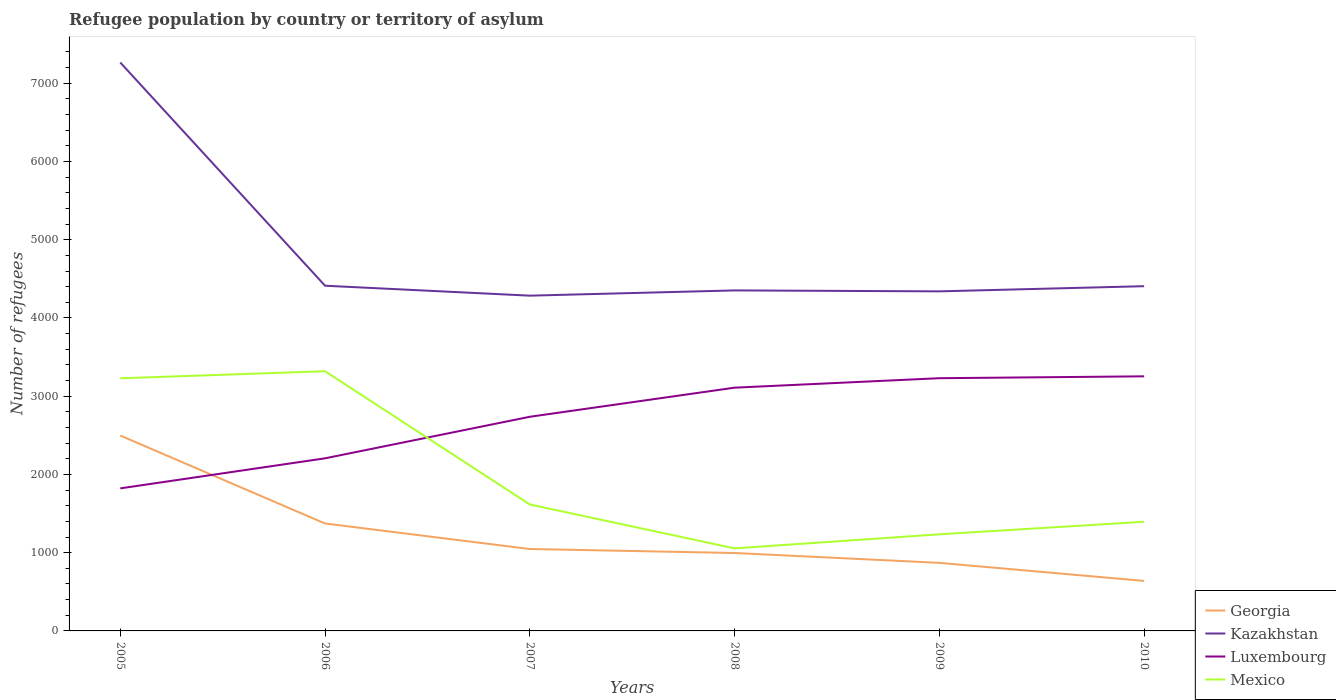How many different coloured lines are there?
Offer a terse response. 4. Is the number of lines equal to the number of legend labels?
Offer a very short reply. Yes. Across all years, what is the maximum number of refugees in Luxembourg?
Ensure brevity in your answer.  1822. In which year was the number of refugees in Mexico maximum?
Your answer should be very brief. 2008. What is the total number of refugees in Kazakhstan in the graph?
Keep it short and to the point. -121. What is the difference between the highest and the second highest number of refugees in Georgia?
Your answer should be compact. 1858. How many lines are there?
Keep it short and to the point. 4. How many years are there in the graph?
Your answer should be very brief. 6. Are the values on the major ticks of Y-axis written in scientific E-notation?
Give a very brief answer. No. Does the graph contain any zero values?
Offer a very short reply. No. Does the graph contain grids?
Make the answer very short. No. Where does the legend appear in the graph?
Your answer should be very brief. Bottom right. How many legend labels are there?
Make the answer very short. 4. How are the legend labels stacked?
Offer a terse response. Vertical. What is the title of the graph?
Offer a very short reply. Refugee population by country or territory of asylum. Does "Tonga" appear as one of the legend labels in the graph?
Provide a succinct answer. No. What is the label or title of the X-axis?
Ensure brevity in your answer.  Years. What is the label or title of the Y-axis?
Give a very brief answer. Number of refugees. What is the Number of refugees in Georgia in 2005?
Your answer should be compact. 2497. What is the Number of refugees of Kazakhstan in 2005?
Provide a short and direct response. 7265. What is the Number of refugees of Luxembourg in 2005?
Make the answer very short. 1822. What is the Number of refugees in Mexico in 2005?
Make the answer very short. 3229. What is the Number of refugees of Georgia in 2006?
Keep it short and to the point. 1373. What is the Number of refugees in Kazakhstan in 2006?
Provide a short and direct response. 4412. What is the Number of refugees in Luxembourg in 2006?
Keep it short and to the point. 2206. What is the Number of refugees in Mexico in 2006?
Your answer should be compact. 3319. What is the Number of refugees of Georgia in 2007?
Your answer should be compact. 1047. What is the Number of refugees in Kazakhstan in 2007?
Offer a terse response. 4285. What is the Number of refugees of Luxembourg in 2007?
Your response must be concise. 2737. What is the Number of refugees in Mexico in 2007?
Your response must be concise. 1616. What is the Number of refugees in Georgia in 2008?
Your response must be concise. 996. What is the Number of refugees in Kazakhstan in 2008?
Ensure brevity in your answer.  4352. What is the Number of refugees in Luxembourg in 2008?
Keep it short and to the point. 3109. What is the Number of refugees of Mexico in 2008?
Provide a succinct answer. 1055. What is the Number of refugees in Georgia in 2009?
Provide a short and direct response. 870. What is the Number of refugees of Kazakhstan in 2009?
Make the answer very short. 4340. What is the Number of refugees of Luxembourg in 2009?
Make the answer very short. 3230. What is the Number of refugees in Mexico in 2009?
Offer a terse response. 1235. What is the Number of refugees in Georgia in 2010?
Provide a short and direct response. 639. What is the Number of refugees in Kazakhstan in 2010?
Your answer should be compact. 4406. What is the Number of refugees in Luxembourg in 2010?
Your answer should be very brief. 3254. What is the Number of refugees in Mexico in 2010?
Offer a terse response. 1395. Across all years, what is the maximum Number of refugees in Georgia?
Keep it short and to the point. 2497. Across all years, what is the maximum Number of refugees in Kazakhstan?
Your answer should be very brief. 7265. Across all years, what is the maximum Number of refugees in Luxembourg?
Keep it short and to the point. 3254. Across all years, what is the maximum Number of refugees of Mexico?
Provide a short and direct response. 3319. Across all years, what is the minimum Number of refugees in Georgia?
Keep it short and to the point. 639. Across all years, what is the minimum Number of refugees of Kazakhstan?
Provide a short and direct response. 4285. Across all years, what is the minimum Number of refugees of Luxembourg?
Your response must be concise. 1822. Across all years, what is the minimum Number of refugees of Mexico?
Your answer should be very brief. 1055. What is the total Number of refugees in Georgia in the graph?
Offer a very short reply. 7422. What is the total Number of refugees in Kazakhstan in the graph?
Your answer should be compact. 2.91e+04. What is the total Number of refugees in Luxembourg in the graph?
Give a very brief answer. 1.64e+04. What is the total Number of refugees in Mexico in the graph?
Give a very brief answer. 1.18e+04. What is the difference between the Number of refugees of Georgia in 2005 and that in 2006?
Ensure brevity in your answer.  1124. What is the difference between the Number of refugees in Kazakhstan in 2005 and that in 2006?
Your answer should be compact. 2853. What is the difference between the Number of refugees in Luxembourg in 2005 and that in 2006?
Your response must be concise. -384. What is the difference between the Number of refugees of Mexico in 2005 and that in 2006?
Keep it short and to the point. -90. What is the difference between the Number of refugees of Georgia in 2005 and that in 2007?
Ensure brevity in your answer.  1450. What is the difference between the Number of refugees in Kazakhstan in 2005 and that in 2007?
Offer a terse response. 2980. What is the difference between the Number of refugees in Luxembourg in 2005 and that in 2007?
Give a very brief answer. -915. What is the difference between the Number of refugees in Mexico in 2005 and that in 2007?
Your response must be concise. 1613. What is the difference between the Number of refugees of Georgia in 2005 and that in 2008?
Make the answer very short. 1501. What is the difference between the Number of refugees in Kazakhstan in 2005 and that in 2008?
Provide a succinct answer. 2913. What is the difference between the Number of refugees of Luxembourg in 2005 and that in 2008?
Give a very brief answer. -1287. What is the difference between the Number of refugees of Mexico in 2005 and that in 2008?
Your answer should be compact. 2174. What is the difference between the Number of refugees in Georgia in 2005 and that in 2009?
Provide a short and direct response. 1627. What is the difference between the Number of refugees in Kazakhstan in 2005 and that in 2009?
Ensure brevity in your answer.  2925. What is the difference between the Number of refugees of Luxembourg in 2005 and that in 2009?
Make the answer very short. -1408. What is the difference between the Number of refugees in Mexico in 2005 and that in 2009?
Your answer should be very brief. 1994. What is the difference between the Number of refugees of Georgia in 2005 and that in 2010?
Provide a short and direct response. 1858. What is the difference between the Number of refugees in Kazakhstan in 2005 and that in 2010?
Your answer should be very brief. 2859. What is the difference between the Number of refugees of Luxembourg in 2005 and that in 2010?
Make the answer very short. -1432. What is the difference between the Number of refugees of Mexico in 2005 and that in 2010?
Your answer should be very brief. 1834. What is the difference between the Number of refugees of Georgia in 2006 and that in 2007?
Your response must be concise. 326. What is the difference between the Number of refugees in Kazakhstan in 2006 and that in 2007?
Ensure brevity in your answer.  127. What is the difference between the Number of refugees in Luxembourg in 2006 and that in 2007?
Ensure brevity in your answer.  -531. What is the difference between the Number of refugees in Mexico in 2006 and that in 2007?
Keep it short and to the point. 1703. What is the difference between the Number of refugees in Georgia in 2006 and that in 2008?
Ensure brevity in your answer.  377. What is the difference between the Number of refugees in Luxembourg in 2006 and that in 2008?
Your answer should be compact. -903. What is the difference between the Number of refugees in Mexico in 2006 and that in 2008?
Provide a succinct answer. 2264. What is the difference between the Number of refugees in Georgia in 2006 and that in 2009?
Provide a short and direct response. 503. What is the difference between the Number of refugees in Luxembourg in 2006 and that in 2009?
Ensure brevity in your answer.  -1024. What is the difference between the Number of refugees of Mexico in 2006 and that in 2009?
Your response must be concise. 2084. What is the difference between the Number of refugees in Georgia in 2006 and that in 2010?
Ensure brevity in your answer.  734. What is the difference between the Number of refugees of Kazakhstan in 2006 and that in 2010?
Provide a succinct answer. 6. What is the difference between the Number of refugees in Luxembourg in 2006 and that in 2010?
Give a very brief answer. -1048. What is the difference between the Number of refugees of Mexico in 2006 and that in 2010?
Keep it short and to the point. 1924. What is the difference between the Number of refugees in Kazakhstan in 2007 and that in 2008?
Offer a very short reply. -67. What is the difference between the Number of refugees of Luxembourg in 2007 and that in 2008?
Make the answer very short. -372. What is the difference between the Number of refugees in Mexico in 2007 and that in 2008?
Make the answer very short. 561. What is the difference between the Number of refugees of Georgia in 2007 and that in 2009?
Ensure brevity in your answer.  177. What is the difference between the Number of refugees of Kazakhstan in 2007 and that in 2009?
Offer a very short reply. -55. What is the difference between the Number of refugees of Luxembourg in 2007 and that in 2009?
Give a very brief answer. -493. What is the difference between the Number of refugees of Mexico in 2007 and that in 2009?
Make the answer very short. 381. What is the difference between the Number of refugees of Georgia in 2007 and that in 2010?
Offer a terse response. 408. What is the difference between the Number of refugees of Kazakhstan in 2007 and that in 2010?
Offer a terse response. -121. What is the difference between the Number of refugees in Luxembourg in 2007 and that in 2010?
Keep it short and to the point. -517. What is the difference between the Number of refugees of Mexico in 2007 and that in 2010?
Ensure brevity in your answer.  221. What is the difference between the Number of refugees in Georgia in 2008 and that in 2009?
Offer a very short reply. 126. What is the difference between the Number of refugees in Luxembourg in 2008 and that in 2009?
Make the answer very short. -121. What is the difference between the Number of refugees in Mexico in 2008 and that in 2009?
Provide a short and direct response. -180. What is the difference between the Number of refugees of Georgia in 2008 and that in 2010?
Provide a succinct answer. 357. What is the difference between the Number of refugees of Kazakhstan in 2008 and that in 2010?
Keep it short and to the point. -54. What is the difference between the Number of refugees of Luxembourg in 2008 and that in 2010?
Offer a terse response. -145. What is the difference between the Number of refugees of Mexico in 2008 and that in 2010?
Provide a succinct answer. -340. What is the difference between the Number of refugees of Georgia in 2009 and that in 2010?
Keep it short and to the point. 231. What is the difference between the Number of refugees in Kazakhstan in 2009 and that in 2010?
Ensure brevity in your answer.  -66. What is the difference between the Number of refugees of Mexico in 2009 and that in 2010?
Offer a terse response. -160. What is the difference between the Number of refugees in Georgia in 2005 and the Number of refugees in Kazakhstan in 2006?
Provide a succinct answer. -1915. What is the difference between the Number of refugees of Georgia in 2005 and the Number of refugees of Luxembourg in 2006?
Give a very brief answer. 291. What is the difference between the Number of refugees of Georgia in 2005 and the Number of refugees of Mexico in 2006?
Offer a very short reply. -822. What is the difference between the Number of refugees of Kazakhstan in 2005 and the Number of refugees of Luxembourg in 2006?
Provide a short and direct response. 5059. What is the difference between the Number of refugees of Kazakhstan in 2005 and the Number of refugees of Mexico in 2006?
Your answer should be compact. 3946. What is the difference between the Number of refugees in Luxembourg in 2005 and the Number of refugees in Mexico in 2006?
Keep it short and to the point. -1497. What is the difference between the Number of refugees of Georgia in 2005 and the Number of refugees of Kazakhstan in 2007?
Ensure brevity in your answer.  -1788. What is the difference between the Number of refugees in Georgia in 2005 and the Number of refugees in Luxembourg in 2007?
Offer a very short reply. -240. What is the difference between the Number of refugees of Georgia in 2005 and the Number of refugees of Mexico in 2007?
Make the answer very short. 881. What is the difference between the Number of refugees of Kazakhstan in 2005 and the Number of refugees of Luxembourg in 2007?
Your answer should be compact. 4528. What is the difference between the Number of refugees of Kazakhstan in 2005 and the Number of refugees of Mexico in 2007?
Offer a very short reply. 5649. What is the difference between the Number of refugees of Luxembourg in 2005 and the Number of refugees of Mexico in 2007?
Your answer should be compact. 206. What is the difference between the Number of refugees of Georgia in 2005 and the Number of refugees of Kazakhstan in 2008?
Provide a short and direct response. -1855. What is the difference between the Number of refugees in Georgia in 2005 and the Number of refugees in Luxembourg in 2008?
Your answer should be very brief. -612. What is the difference between the Number of refugees of Georgia in 2005 and the Number of refugees of Mexico in 2008?
Provide a short and direct response. 1442. What is the difference between the Number of refugees of Kazakhstan in 2005 and the Number of refugees of Luxembourg in 2008?
Provide a succinct answer. 4156. What is the difference between the Number of refugees of Kazakhstan in 2005 and the Number of refugees of Mexico in 2008?
Ensure brevity in your answer.  6210. What is the difference between the Number of refugees in Luxembourg in 2005 and the Number of refugees in Mexico in 2008?
Your response must be concise. 767. What is the difference between the Number of refugees of Georgia in 2005 and the Number of refugees of Kazakhstan in 2009?
Keep it short and to the point. -1843. What is the difference between the Number of refugees of Georgia in 2005 and the Number of refugees of Luxembourg in 2009?
Provide a succinct answer. -733. What is the difference between the Number of refugees in Georgia in 2005 and the Number of refugees in Mexico in 2009?
Your answer should be compact. 1262. What is the difference between the Number of refugees of Kazakhstan in 2005 and the Number of refugees of Luxembourg in 2009?
Offer a very short reply. 4035. What is the difference between the Number of refugees in Kazakhstan in 2005 and the Number of refugees in Mexico in 2009?
Give a very brief answer. 6030. What is the difference between the Number of refugees in Luxembourg in 2005 and the Number of refugees in Mexico in 2009?
Ensure brevity in your answer.  587. What is the difference between the Number of refugees of Georgia in 2005 and the Number of refugees of Kazakhstan in 2010?
Give a very brief answer. -1909. What is the difference between the Number of refugees of Georgia in 2005 and the Number of refugees of Luxembourg in 2010?
Ensure brevity in your answer.  -757. What is the difference between the Number of refugees in Georgia in 2005 and the Number of refugees in Mexico in 2010?
Your answer should be very brief. 1102. What is the difference between the Number of refugees in Kazakhstan in 2005 and the Number of refugees in Luxembourg in 2010?
Keep it short and to the point. 4011. What is the difference between the Number of refugees in Kazakhstan in 2005 and the Number of refugees in Mexico in 2010?
Give a very brief answer. 5870. What is the difference between the Number of refugees of Luxembourg in 2005 and the Number of refugees of Mexico in 2010?
Offer a very short reply. 427. What is the difference between the Number of refugees of Georgia in 2006 and the Number of refugees of Kazakhstan in 2007?
Give a very brief answer. -2912. What is the difference between the Number of refugees of Georgia in 2006 and the Number of refugees of Luxembourg in 2007?
Provide a succinct answer. -1364. What is the difference between the Number of refugees in Georgia in 2006 and the Number of refugees in Mexico in 2007?
Provide a succinct answer. -243. What is the difference between the Number of refugees in Kazakhstan in 2006 and the Number of refugees in Luxembourg in 2007?
Make the answer very short. 1675. What is the difference between the Number of refugees of Kazakhstan in 2006 and the Number of refugees of Mexico in 2007?
Provide a short and direct response. 2796. What is the difference between the Number of refugees in Luxembourg in 2006 and the Number of refugees in Mexico in 2007?
Your response must be concise. 590. What is the difference between the Number of refugees of Georgia in 2006 and the Number of refugees of Kazakhstan in 2008?
Your answer should be compact. -2979. What is the difference between the Number of refugees in Georgia in 2006 and the Number of refugees in Luxembourg in 2008?
Offer a very short reply. -1736. What is the difference between the Number of refugees of Georgia in 2006 and the Number of refugees of Mexico in 2008?
Ensure brevity in your answer.  318. What is the difference between the Number of refugees of Kazakhstan in 2006 and the Number of refugees of Luxembourg in 2008?
Ensure brevity in your answer.  1303. What is the difference between the Number of refugees in Kazakhstan in 2006 and the Number of refugees in Mexico in 2008?
Offer a terse response. 3357. What is the difference between the Number of refugees in Luxembourg in 2006 and the Number of refugees in Mexico in 2008?
Offer a very short reply. 1151. What is the difference between the Number of refugees of Georgia in 2006 and the Number of refugees of Kazakhstan in 2009?
Offer a very short reply. -2967. What is the difference between the Number of refugees in Georgia in 2006 and the Number of refugees in Luxembourg in 2009?
Offer a terse response. -1857. What is the difference between the Number of refugees in Georgia in 2006 and the Number of refugees in Mexico in 2009?
Your response must be concise. 138. What is the difference between the Number of refugees in Kazakhstan in 2006 and the Number of refugees in Luxembourg in 2009?
Your answer should be compact. 1182. What is the difference between the Number of refugees in Kazakhstan in 2006 and the Number of refugees in Mexico in 2009?
Your response must be concise. 3177. What is the difference between the Number of refugees of Luxembourg in 2006 and the Number of refugees of Mexico in 2009?
Provide a short and direct response. 971. What is the difference between the Number of refugees of Georgia in 2006 and the Number of refugees of Kazakhstan in 2010?
Give a very brief answer. -3033. What is the difference between the Number of refugees of Georgia in 2006 and the Number of refugees of Luxembourg in 2010?
Your answer should be compact. -1881. What is the difference between the Number of refugees in Georgia in 2006 and the Number of refugees in Mexico in 2010?
Ensure brevity in your answer.  -22. What is the difference between the Number of refugees of Kazakhstan in 2006 and the Number of refugees of Luxembourg in 2010?
Your answer should be compact. 1158. What is the difference between the Number of refugees of Kazakhstan in 2006 and the Number of refugees of Mexico in 2010?
Provide a succinct answer. 3017. What is the difference between the Number of refugees in Luxembourg in 2006 and the Number of refugees in Mexico in 2010?
Provide a succinct answer. 811. What is the difference between the Number of refugees of Georgia in 2007 and the Number of refugees of Kazakhstan in 2008?
Provide a succinct answer. -3305. What is the difference between the Number of refugees of Georgia in 2007 and the Number of refugees of Luxembourg in 2008?
Your answer should be very brief. -2062. What is the difference between the Number of refugees of Kazakhstan in 2007 and the Number of refugees of Luxembourg in 2008?
Your answer should be very brief. 1176. What is the difference between the Number of refugees of Kazakhstan in 2007 and the Number of refugees of Mexico in 2008?
Give a very brief answer. 3230. What is the difference between the Number of refugees in Luxembourg in 2007 and the Number of refugees in Mexico in 2008?
Keep it short and to the point. 1682. What is the difference between the Number of refugees in Georgia in 2007 and the Number of refugees in Kazakhstan in 2009?
Your answer should be very brief. -3293. What is the difference between the Number of refugees in Georgia in 2007 and the Number of refugees in Luxembourg in 2009?
Make the answer very short. -2183. What is the difference between the Number of refugees in Georgia in 2007 and the Number of refugees in Mexico in 2009?
Provide a succinct answer. -188. What is the difference between the Number of refugees in Kazakhstan in 2007 and the Number of refugees in Luxembourg in 2009?
Keep it short and to the point. 1055. What is the difference between the Number of refugees in Kazakhstan in 2007 and the Number of refugees in Mexico in 2009?
Ensure brevity in your answer.  3050. What is the difference between the Number of refugees in Luxembourg in 2007 and the Number of refugees in Mexico in 2009?
Offer a very short reply. 1502. What is the difference between the Number of refugees of Georgia in 2007 and the Number of refugees of Kazakhstan in 2010?
Give a very brief answer. -3359. What is the difference between the Number of refugees in Georgia in 2007 and the Number of refugees in Luxembourg in 2010?
Your response must be concise. -2207. What is the difference between the Number of refugees of Georgia in 2007 and the Number of refugees of Mexico in 2010?
Provide a short and direct response. -348. What is the difference between the Number of refugees in Kazakhstan in 2007 and the Number of refugees in Luxembourg in 2010?
Ensure brevity in your answer.  1031. What is the difference between the Number of refugees of Kazakhstan in 2007 and the Number of refugees of Mexico in 2010?
Your answer should be compact. 2890. What is the difference between the Number of refugees of Luxembourg in 2007 and the Number of refugees of Mexico in 2010?
Give a very brief answer. 1342. What is the difference between the Number of refugees in Georgia in 2008 and the Number of refugees in Kazakhstan in 2009?
Offer a very short reply. -3344. What is the difference between the Number of refugees in Georgia in 2008 and the Number of refugees in Luxembourg in 2009?
Provide a succinct answer. -2234. What is the difference between the Number of refugees of Georgia in 2008 and the Number of refugees of Mexico in 2009?
Your answer should be compact. -239. What is the difference between the Number of refugees in Kazakhstan in 2008 and the Number of refugees in Luxembourg in 2009?
Give a very brief answer. 1122. What is the difference between the Number of refugees of Kazakhstan in 2008 and the Number of refugees of Mexico in 2009?
Your response must be concise. 3117. What is the difference between the Number of refugees in Luxembourg in 2008 and the Number of refugees in Mexico in 2009?
Your answer should be compact. 1874. What is the difference between the Number of refugees of Georgia in 2008 and the Number of refugees of Kazakhstan in 2010?
Offer a terse response. -3410. What is the difference between the Number of refugees in Georgia in 2008 and the Number of refugees in Luxembourg in 2010?
Give a very brief answer. -2258. What is the difference between the Number of refugees in Georgia in 2008 and the Number of refugees in Mexico in 2010?
Give a very brief answer. -399. What is the difference between the Number of refugees in Kazakhstan in 2008 and the Number of refugees in Luxembourg in 2010?
Ensure brevity in your answer.  1098. What is the difference between the Number of refugees of Kazakhstan in 2008 and the Number of refugees of Mexico in 2010?
Keep it short and to the point. 2957. What is the difference between the Number of refugees in Luxembourg in 2008 and the Number of refugees in Mexico in 2010?
Offer a terse response. 1714. What is the difference between the Number of refugees of Georgia in 2009 and the Number of refugees of Kazakhstan in 2010?
Your response must be concise. -3536. What is the difference between the Number of refugees of Georgia in 2009 and the Number of refugees of Luxembourg in 2010?
Offer a very short reply. -2384. What is the difference between the Number of refugees of Georgia in 2009 and the Number of refugees of Mexico in 2010?
Offer a terse response. -525. What is the difference between the Number of refugees of Kazakhstan in 2009 and the Number of refugees of Luxembourg in 2010?
Make the answer very short. 1086. What is the difference between the Number of refugees in Kazakhstan in 2009 and the Number of refugees in Mexico in 2010?
Provide a succinct answer. 2945. What is the difference between the Number of refugees of Luxembourg in 2009 and the Number of refugees of Mexico in 2010?
Offer a terse response. 1835. What is the average Number of refugees in Georgia per year?
Your answer should be compact. 1237. What is the average Number of refugees of Kazakhstan per year?
Offer a very short reply. 4843.33. What is the average Number of refugees in Luxembourg per year?
Ensure brevity in your answer.  2726.33. What is the average Number of refugees of Mexico per year?
Provide a short and direct response. 1974.83. In the year 2005, what is the difference between the Number of refugees of Georgia and Number of refugees of Kazakhstan?
Provide a succinct answer. -4768. In the year 2005, what is the difference between the Number of refugees in Georgia and Number of refugees in Luxembourg?
Give a very brief answer. 675. In the year 2005, what is the difference between the Number of refugees in Georgia and Number of refugees in Mexico?
Your answer should be very brief. -732. In the year 2005, what is the difference between the Number of refugees of Kazakhstan and Number of refugees of Luxembourg?
Keep it short and to the point. 5443. In the year 2005, what is the difference between the Number of refugees in Kazakhstan and Number of refugees in Mexico?
Give a very brief answer. 4036. In the year 2005, what is the difference between the Number of refugees in Luxembourg and Number of refugees in Mexico?
Make the answer very short. -1407. In the year 2006, what is the difference between the Number of refugees of Georgia and Number of refugees of Kazakhstan?
Keep it short and to the point. -3039. In the year 2006, what is the difference between the Number of refugees in Georgia and Number of refugees in Luxembourg?
Provide a short and direct response. -833. In the year 2006, what is the difference between the Number of refugees of Georgia and Number of refugees of Mexico?
Ensure brevity in your answer.  -1946. In the year 2006, what is the difference between the Number of refugees of Kazakhstan and Number of refugees of Luxembourg?
Your answer should be compact. 2206. In the year 2006, what is the difference between the Number of refugees in Kazakhstan and Number of refugees in Mexico?
Your response must be concise. 1093. In the year 2006, what is the difference between the Number of refugees of Luxembourg and Number of refugees of Mexico?
Your answer should be very brief. -1113. In the year 2007, what is the difference between the Number of refugees of Georgia and Number of refugees of Kazakhstan?
Keep it short and to the point. -3238. In the year 2007, what is the difference between the Number of refugees in Georgia and Number of refugees in Luxembourg?
Provide a succinct answer. -1690. In the year 2007, what is the difference between the Number of refugees in Georgia and Number of refugees in Mexico?
Offer a very short reply. -569. In the year 2007, what is the difference between the Number of refugees of Kazakhstan and Number of refugees of Luxembourg?
Make the answer very short. 1548. In the year 2007, what is the difference between the Number of refugees of Kazakhstan and Number of refugees of Mexico?
Your response must be concise. 2669. In the year 2007, what is the difference between the Number of refugees in Luxembourg and Number of refugees in Mexico?
Offer a very short reply. 1121. In the year 2008, what is the difference between the Number of refugees in Georgia and Number of refugees in Kazakhstan?
Make the answer very short. -3356. In the year 2008, what is the difference between the Number of refugees of Georgia and Number of refugees of Luxembourg?
Offer a very short reply. -2113. In the year 2008, what is the difference between the Number of refugees in Georgia and Number of refugees in Mexico?
Offer a terse response. -59. In the year 2008, what is the difference between the Number of refugees in Kazakhstan and Number of refugees in Luxembourg?
Make the answer very short. 1243. In the year 2008, what is the difference between the Number of refugees of Kazakhstan and Number of refugees of Mexico?
Make the answer very short. 3297. In the year 2008, what is the difference between the Number of refugees of Luxembourg and Number of refugees of Mexico?
Provide a succinct answer. 2054. In the year 2009, what is the difference between the Number of refugees in Georgia and Number of refugees in Kazakhstan?
Your answer should be very brief. -3470. In the year 2009, what is the difference between the Number of refugees in Georgia and Number of refugees in Luxembourg?
Offer a terse response. -2360. In the year 2009, what is the difference between the Number of refugees of Georgia and Number of refugees of Mexico?
Provide a succinct answer. -365. In the year 2009, what is the difference between the Number of refugees of Kazakhstan and Number of refugees of Luxembourg?
Your response must be concise. 1110. In the year 2009, what is the difference between the Number of refugees of Kazakhstan and Number of refugees of Mexico?
Provide a short and direct response. 3105. In the year 2009, what is the difference between the Number of refugees of Luxembourg and Number of refugees of Mexico?
Offer a terse response. 1995. In the year 2010, what is the difference between the Number of refugees in Georgia and Number of refugees in Kazakhstan?
Offer a very short reply. -3767. In the year 2010, what is the difference between the Number of refugees in Georgia and Number of refugees in Luxembourg?
Offer a very short reply. -2615. In the year 2010, what is the difference between the Number of refugees in Georgia and Number of refugees in Mexico?
Your answer should be compact. -756. In the year 2010, what is the difference between the Number of refugees in Kazakhstan and Number of refugees in Luxembourg?
Your answer should be compact. 1152. In the year 2010, what is the difference between the Number of refugees of Kazakhstan and Number of refugees of Mexico?
Ensure brevity in your answer.  3011. In the year 2010, what is the difference between the Number of refugees in Luxembourg and Number of refugees in Mexico?
Offer a terse response. 1859. What is the ratio of the Number of refugees of Georgia in 2005 to that in 2006?
Offer a very short reply. 1.82. What is the ratio of the Number of refugees in Kazakhstan in 2005 to that in 2006?
Your response must be concise. 1.65. What is the ratio of the Number of refugees in Luxembourg in 2005 to that in 2006?
Your answer should be compact. 0.83. What is the ratio of the Number of refugees of Mexico in 2005 to that in 2006?
Keep it short and to the point. 0.97. What is the ratio of the Number of refugees of Georgia in 2005 to that in 2007?
Provide a succinct answer. 2.38. What is the ratio of the Number of refugees in Kazakhstan in 2005 to that in 2007?
Your answer should be compact. 1.7. What is the ratio of the Number of refugees of Luxembourg in 2005 to that in 2007?
Your answer should be compact. 0.67. What is the ratio of the Number of refugees in Mexico in 2005 to that in 2007?
Offer a very short reply. 2. What is the ratio of the Number of refugees in Georgia in 2005 to that in 2008?
Your answer should be compact. 2.51. What is the ratio of the Number of refugees of Kazakhstan in 2005 to that in 2008?
Provide a short and direct response. 1.67. What is the ratio of the Number of refugees in Luxembourg in 2005 to that in 2008?
Give a very brief answer. 0.59. What is the ratio of the Number of refugees of Mexico in 2005 to that in 2008?
Make the answer very short. 3.06. What is the ratio of the Number of refugees in Georgia in 2005 to that in 2009?
Provide a succinct answer. 2.87. What is the ratio of the Number of refugees of Kazakhstan in 2005 to that in 2009?
Your answer should be very brief. 1.67. What is the ratio of the Number of refugees of Luxembourg in 2005 to that in 2009?
Your answer should be very brief. 0.56. What is the ratio of the Number of refugees of Mexico in 2005 to that in 2009?
Offer a terse response. 2.61. What is the ratio of the Number of refugees of Georgia in 2005 to that in 2010?
Your answer should be compact. 3.91. What is the ratio of the Number of refugees of Kazakhstan in 2005 to that in 2010?
Your answer should be very brief. 1.65. What is the ratio of the Number of refugees in Luxembourg in 2005 to that in 2010?
Offer a very short reply. 0.56. What is the ratio of the Number of refugees of Mexico in 2005 to that in 2010?
Make the answer very short. 2.31. What is the ratio of the Number of refugees in Georgia in 2006 to that in 2007?
Keep it short and to the point. 1.31. What is the ratio of the Number of refugees of Kazakhstan in 2006 to that in 2007?
Keep it short and to the point. 1.03. What is the ratio of the Number of refugees in Luxembourg in 2006 to that in 2007?
Provide a succinct answer. 0.81. What is the ratio of the Number of refugees of Mexico in 2006 to that in 2007?
Offer a very short reply. 2.05. What is the ratio of the Number of refugees in Georgia in 2006 to that in 2008?
Your answer should be compact. 1.38. What is the ratio of the Number of refugees of Kazakhstan in 2006 to that in 2008?
Your response must be concise. 1.01. What is the ratio of the Number of refugees in Luxembourg in 2006 to that in 2008?
Your answer should be compact. 0.71. What is the ratio of the Number of refugees in Mexico in 2006 to that in 2008?
Give a very brief answer. 3.15. What is the ratio of the Number of refugees in Georgia in 2006 to that in 2009?
Offer a terse response. 1.58. What is the ratio of the Number of refugees in Kazakhstan in 2006 to that in 2009?
Keep it short and to the point. 1.02. What is the ratio of the Number of refugees in Luxembourg in 2006 to that in 2009?
Give a very brief answer. 0.68. What is the ratio of the Number of refugees of Mexico in 2006 to that in 2009?
Provide a succinct answer. 2.69. What is the ratio of the Number of refugees in Georgia in 2006 to that in 2010?
Offer a very short reply. 2.15. What is the ratio of the Number of refugees of Luxembourg in 2006 to that in 2010?
Offer a terse response. 0.68. What is the ratio of the Number of refugees in Mexico in 2006 to that in 2010?
Your answer should be compact. 2.38. What is the ratio of the Number of refugees in Georgia in 2007 to that in 2008?
Your answer should be compact. 1.05. What is the ratio of the Number of refugees in Kazakhstan in 2007 to that in 2008?
Your response must be concise. 0.98. What is the ratio of the Number of refugees of Luxembourg in 2007 to that in 2008?
Provide a succinct answer. 0.88. What is the ratio of the Number of refugees in Mexico in 2007 to that in 2008?
Make the answer very short. 1.53. What is the ratio of the Number of refugees in Georgia in 2007 to that in 2009?
Offer a terse response. 1.2. What is the ratio of the Number of refugees of Kazakhstan in 2007 to that in 2009?
Your answer should be very brief. 0.99. What is the ratio of the Number of refugees of Luxembourg in 2007 to that in 2009?
Make the answer very short. 0.85. What is the ratio of the Number of refugees of Mexico in 2007 to that in 2009?
Offer a terse response. 1.31. What is the ratio of the Number of refugees of Georgia in 2007 to that in 2010?
Give a very brief answer. 1.64. What is the ratio of the Number of refugees of Kazakhstan in 2007 to that in 2010?
Your response must be concise. 0.97. What is the ratio of the Number of refugees in Luxembourg in 2007 to that in 2010?
Offer a terse response. 0.84. What is the ratio of the Number of refugees in Mexico in 2007 to that in 2010?
Keep it short and to the point. 1.16. What is the ratio of the Number of refugees in Georgia in 2008 to that in 2009?
Offer a terse response. 1.14. What is the ratio of the Number of refugees in Luxembourg in 2008 to that in 2009?
Offer a very short reply. 0.96. What is the ratio of the Number of refugees in Mexico in 2008 to that in 2009?
Keep it short and to the point. 0.85. What is the ratio of the Number of refugees in Georgia in 2008 to that in 2010?
Your response must be concise. 1.56. What is the ratio of the Number of refugees of Kazakhstan in 2008 to that in 2010?
Make the answer very short. 0.99. What is the ratio of the Number of refugees of Luxembourg in 2008 to that in 2010?
Provide a succinct answer. 0.96. What is the ratio of the Number of refugees in Mexico in 2008 to that in 2010?
Ensure brevity in your answer.  0.76. What is the ratio of the Number of refugees of Georgia in 2009 to that in 2010?
Give a very brief answer. 1.36. What is the ratio of the Number of refugees of Luxembourg in 2009 to that in 2010?
Your answer should be very brief. 0.99. What is the ratio of the Number of refugees of Mexico in 2009 to that in 2010?
Offer a very short reply. 0.89. What is the difference between the highest and the second highest Number of refugees of Georgia?
Ensure brevity in your answer.  1124. What is the difference between the highest and the second highest Number of refugees in Kazakhstan?
Make the answer very short. 2853. What is the difference between the highest and the second highest Number of refugees in Luxembourg?
Ensure brevity in your answer.  24. What is the difference between the highest and the lowest Number of refugees of Georgia?
Your answer should be very brief. 1858. What is the difference between the highest and the lowest Number of refugees of Kazakhstan?
Give a very brief answer. 2980. What is the difference between the highest and the lowest Number of refugees in Luxembourg?
Offer a terse response. 1432. What is the difference between the highest and the lowest Number of refugees of Mexico?
Your answer should be compact. 2264. 